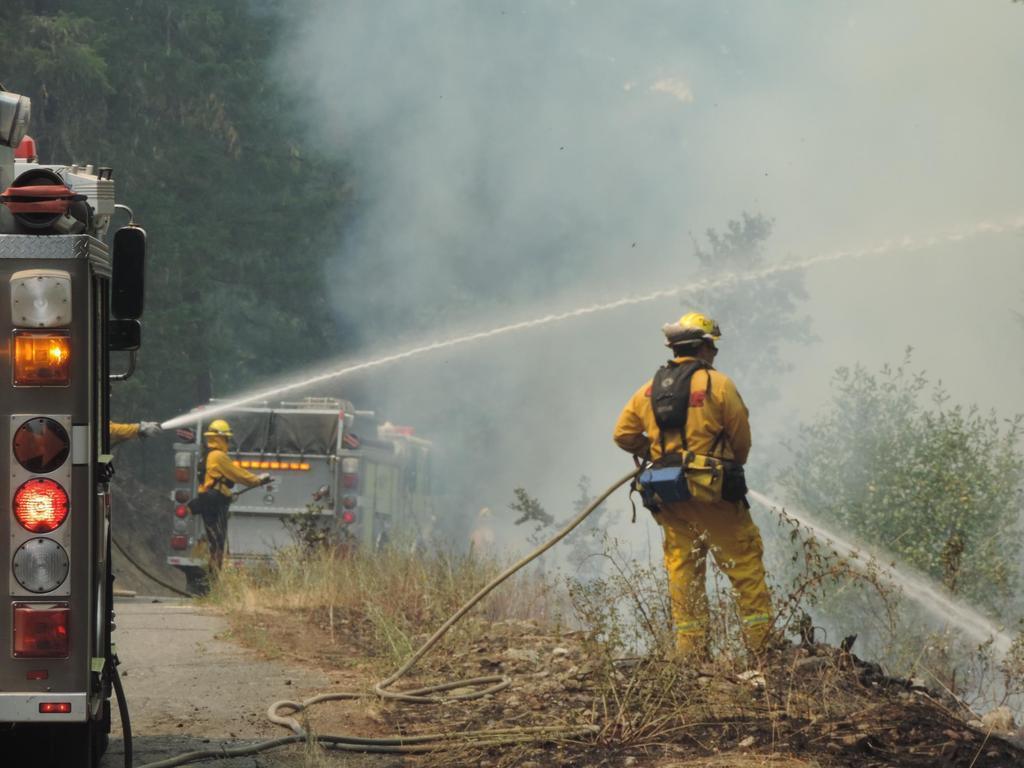Can you describe this image briefly? In this picture there are two people holding water pipes and spraying water and we can see grass and plants. On the left side of the image we can see truncated vehicle on the road. In the background of the image there is a person standing, beside this person we can see a vehicle and we can see trees and smoke. 